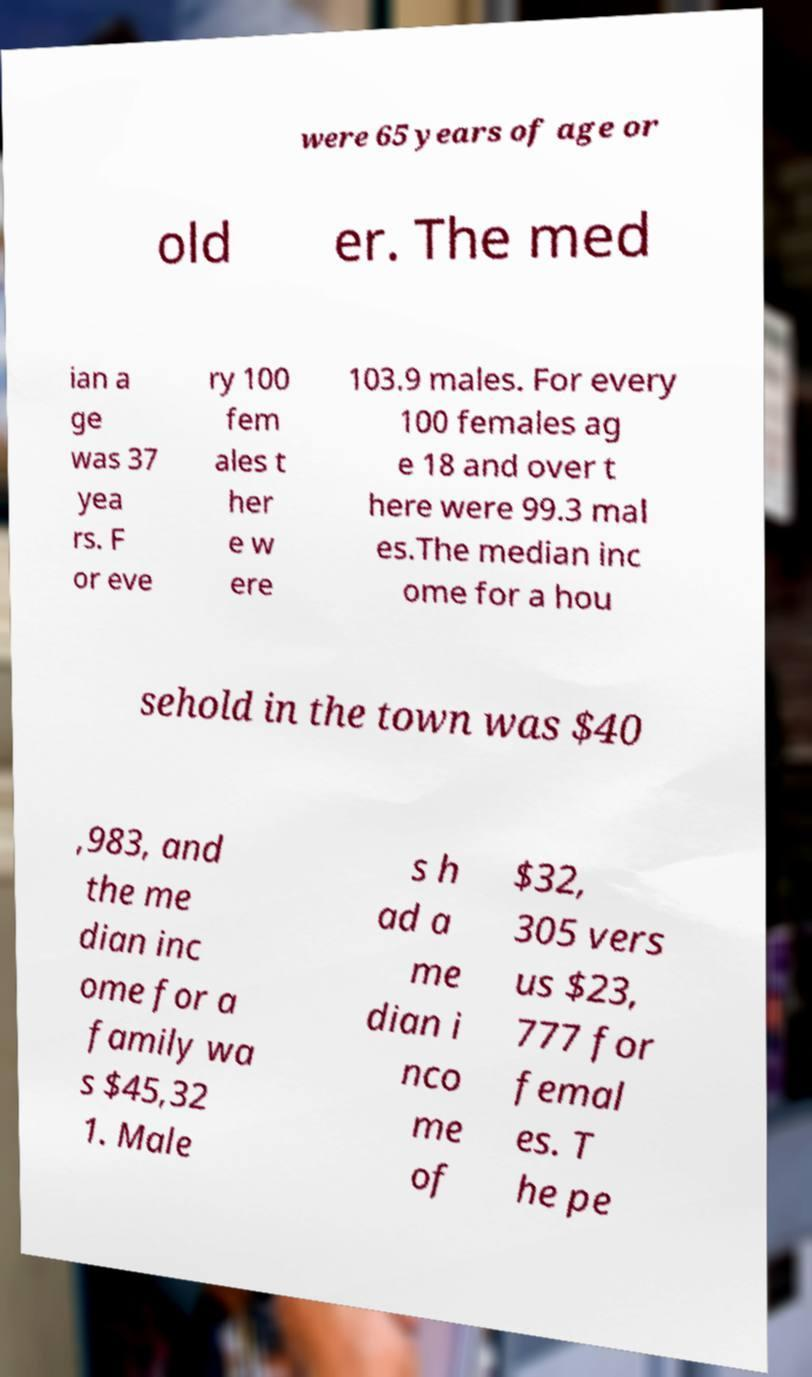Please identify and transcribe the text found in this image. were 65 years of age or old er. The med ian a ge was 37 yea rs. F or eve ry 100 fem ales t her e w ere 103.9 males. For every 100 females ag e 18 and over t here were 99.3 mal es.The median inc ome for a hou sehold in the town was $40 ,983, and the me dian inc ome for a family wa s $45,32 1. Male s h ad a me dian i nco me of $32, 305 vers us $23, 777 for femal es. T he pe 